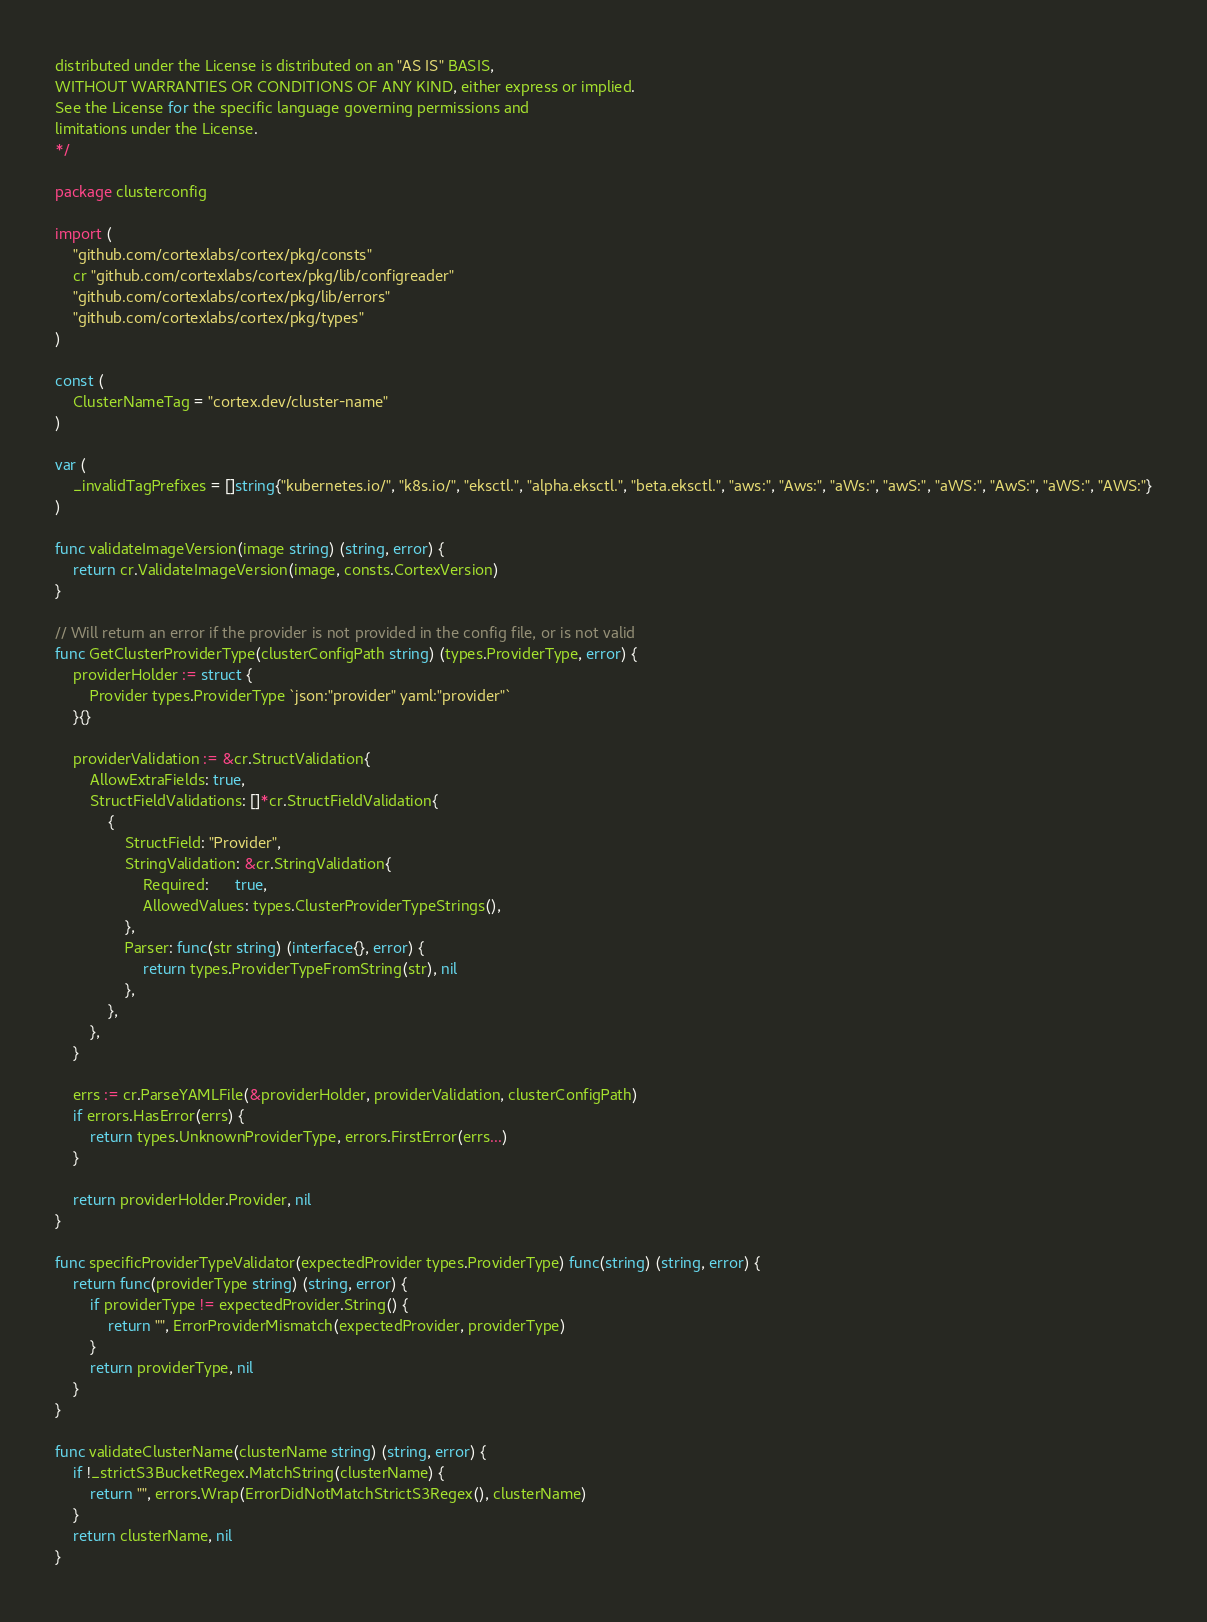Convert code to text. <code><loc_0><loc_0><loc_500><loc_500><_Go_>distributed under the License is distributed on an "AS IS" BASIS,
WITHOUT WARRANTIES OR CONDITIONS OF ANY KIND, either express or implied.
See the License for the specific language governing permissions and
limitations under the License.
*/

package clusterconfig

import (
	"github.com/cortexlabs/cortex/pkg/consts"
	cr "github.com/cortexlabs/cortex/pkg/lib/configreader"
	"github.com/cortexlabs/cortex/pkg/lib/errors"
	"github.com/cortexlabs/cortex/pkg/types"
)

const (
	ClusterNameTag = "cortex.dev/cluster-name"
)

var (
	_invalidTagPrefixes = []string{"kubernetes.io/", "k8s.io/", "eksctl.", "alpha.eksctl.", "beta.eksctl.", "aws:", "Aws:", "aWs:", "awS:", "aWS:", "AwS:", "aWS:", "AWS:"}
)

func validateImageVersion(image string) (string, error) {
	return cr.ValidateImageVersion(image, consts.CortexVersion)
}

// Will return an error if the provider is not provided in the config file, or is not valid
func GetClusterProviderType(clusterConfigPath string) (types.ProviderType, error) {
	providerHolder := struct {
		Provider types.ProviderType `json:"provider" yaml:"provider"`
	}{}

	providerValidation := &cr.StructValidation{
		AllowExtraFields: true,
		StructFieldValidations: []*cr.StructFieldValidation{
			{
				StructField: "Provider",
				StringValidation: &cr.StringValidation{
					Required:      true,
					AllowedValues: types.ClusterProviderTypeStrings(),
				},
				Parser: func(str string) (interface{}, error) {
					return types.ProviderTypeFromString(str), nil
				},
			},
		},
	}

	errs := cr.ParseYAMLFile(&providerHolder, providerValidation, clusterConfigPath)
	if errors.HasError(errs) {
		return types.UnknownProviderType, errors.FirstError(errs...)
	}

	return providerHolder.Provider, nil
}

func specificProviderTypeValidator(expectedProvider types.ProviderType) func(string) (string, error) {
	return func(providerType string) (string, error) {
		if providerType != expectedProvider.String() {
			return "", ErrorProviderMismatch(expectedProvider, providerType)
		}
		return providerType, nil
	}
}

func validateClusterName(clusterName string) (string, error) {
	if !_strictS3BucketRegex.MatchString(clusterName) {
		return "", errors.Wrap(ErrorDidNotMatchStrictS3Regex(), clusterName)
	}
	return clusterName, nil
}
</code> 